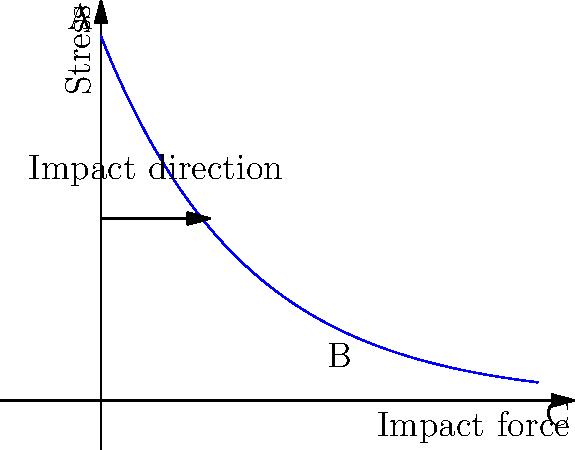In the stress distribution diagram of a smartphone case under drop impact, what does the decreasing exponential curve from point A to C represent, and how does it relate to the design of affordable smartphones for developing countries? To understand the stress distribution in a smartphone case under drop impact:

1. The graph shows stress (y-axis) vs. impact force (x-axis).

2. Point A represents the initial impact point with maximum stress.

3. The curve follows an exponential decay from A to C, described by the equation:

   $$\sigma = \sigma_0 e^{-kx}$$

   Where $\sigma$ is stress, $\sigma_0$ is initial stress, $k$ is a decay constant, and $x$ is distance from impact.

4. This distribution indicates that stress decreases rapidly as we move away from the impact point.

5. For affordable smartphones:
   a) Design should focus on reinforcing high-stress areas (near point A).
   b) Less material can be used in low-stress areas (near point C), reducing costs.
   c) Optimizing material distribution based on this curve can balance durability and affordability.

6. Point B represents a mid-range stress area, where design decisions can significantly affect cost-effectiveness.

7. The rapid stress decrease allows for strategic material allocation, crucial for cost-effective manufacturing in developing markets.

8. Understanding this distribution helps in designing cases that provide adequate protection while minimizing material use and production costs.
Answer: The curve represents stress attenuation from the impact point, guiding cost-effective material distribution for durable yet affordable smartphone case design. 